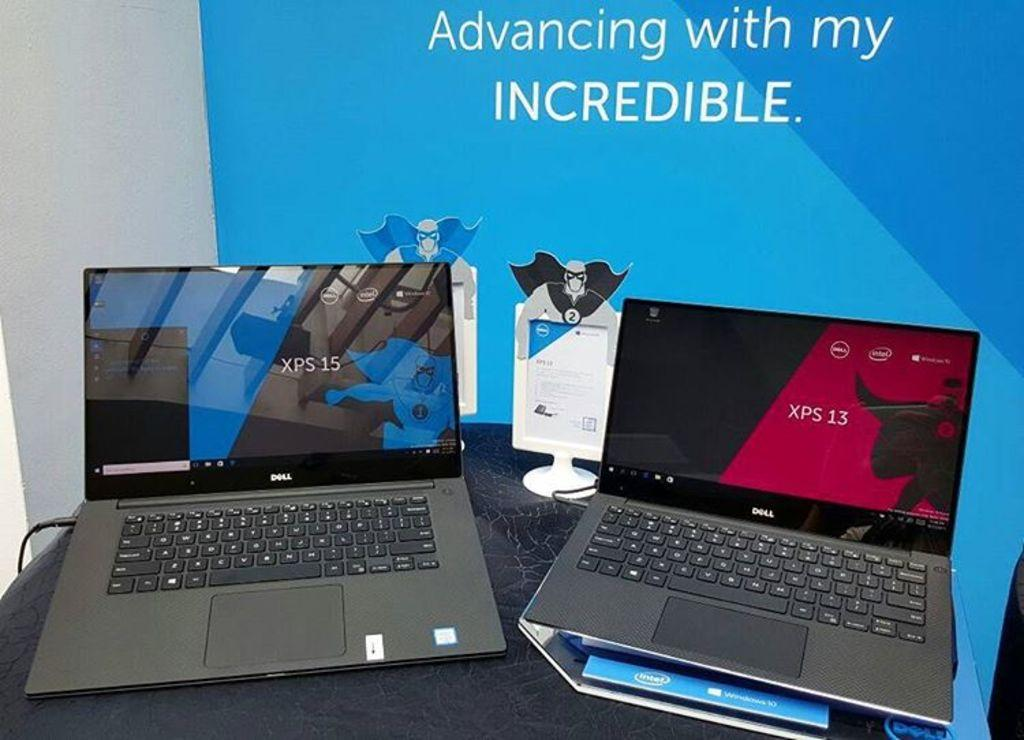<image>
Give a short and clear explanation of the subsequent image. Two Dell laptops are on a table, showing XPS 15 on their screens and a slogan on a blue background behind them. 